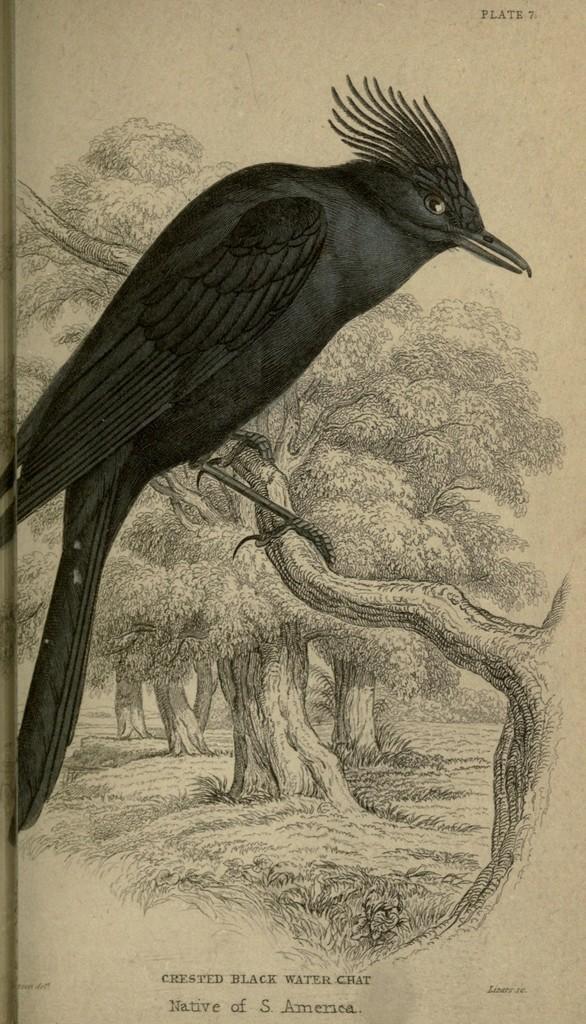Please provide a concise description of this image. In this picture we can see an object seems to be a paper on which we can see the drawing of trees, grass and plants and we can see the drawing of a bird standing on the stem of a tree. At the bottom we can see the text. 